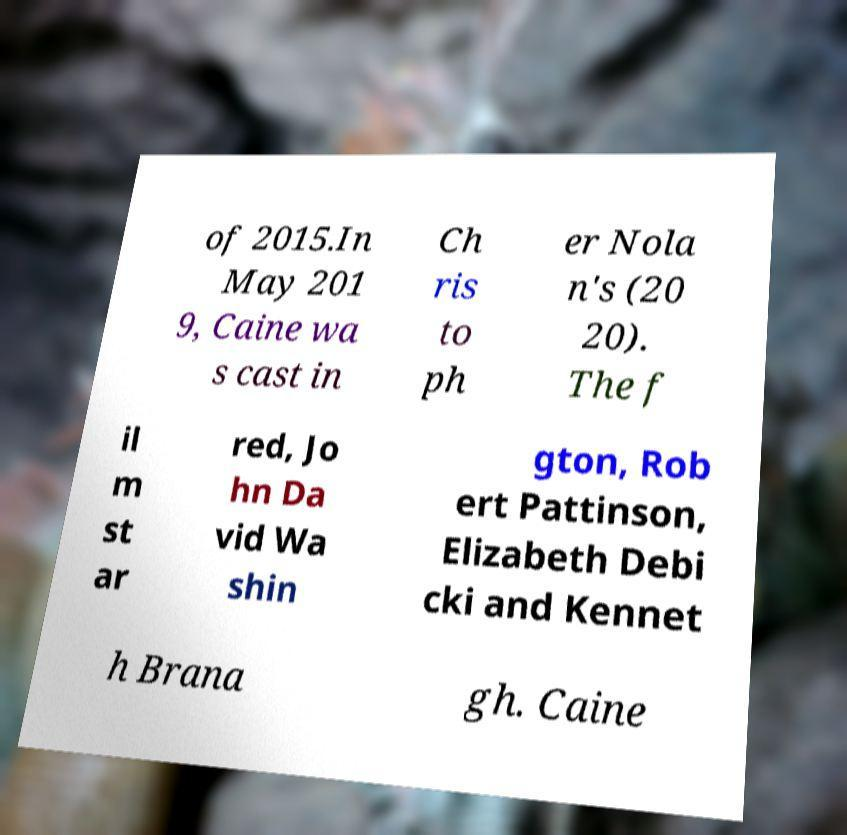Please read and relay the text visible in this image. What does it say? of 2015.In May 201 9, Caine wa s cast in Ch ris to ph er Nola n's (20 20). The f il m st ar red, Jo hn Da vid Wa shin gton, Rob ert Pattinson, Elizabeth Debi cki and Kennet h Brana gh. Caine 